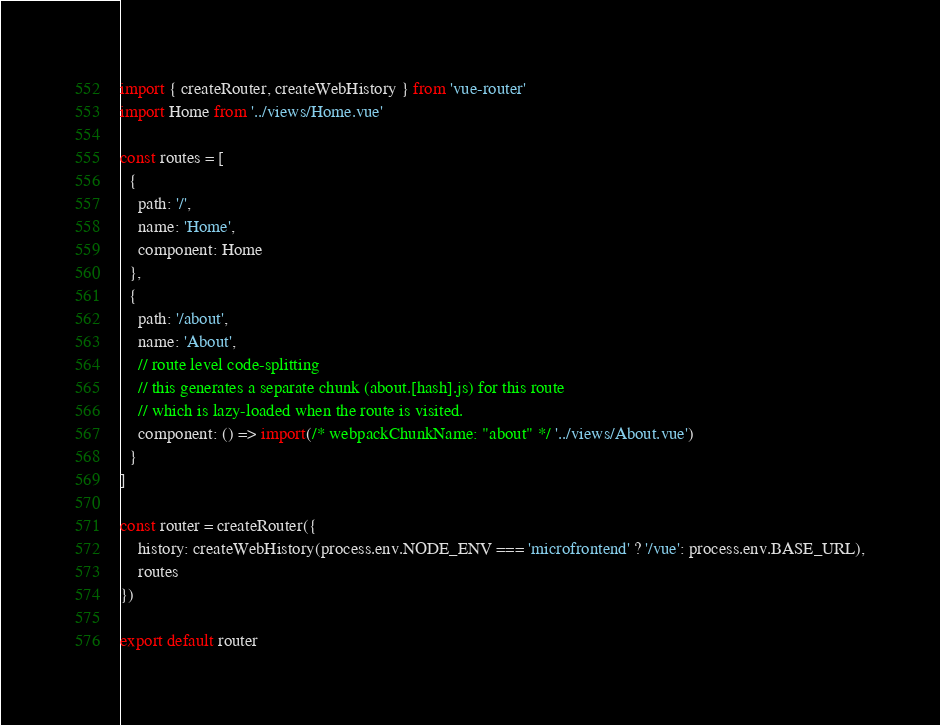Convert code to text. <code><loc_0><loc_0><loc_500><loc_500><_JavaScript_>import { createRouter, createWebHistory } from 'vue-router'
import Home from '../views/Home.vue'

const routes = [
  {
    path: '/',
    name: 'Home',
    component: Home
  },
  {
    path: '/about',
    name: 'About',
    // route level code-splitting
    // this generates a separate chunk (about.[hash].js) for this route
    // which is lazy-loaded when the route is visited.
    component: () => import(/* webpackChunkName: "about" */ '../views/About.vue')
  }
]

const router = createRouter({
	history: createWebHistory(process.env.NODE_ENV === 'microfrontend' ? '/vue': process.env.BASE_URL),
	routes
})

export default router
</code> 